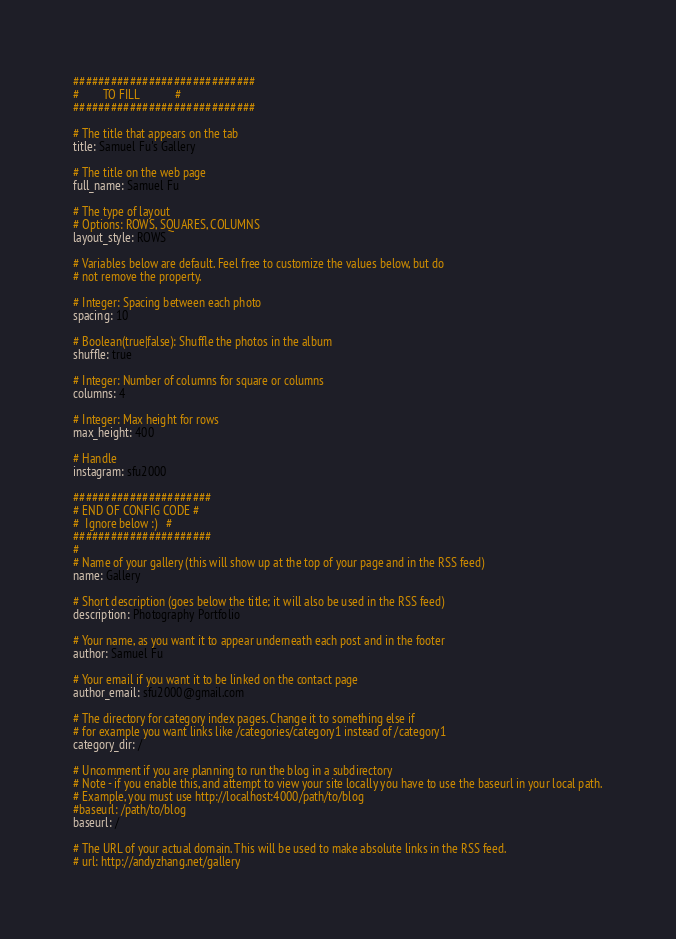<code> <loc_0><loc_0><loc_500><loc_500><_YAML_>#############################
#        TO FILL            #
#############################

# The title that appears on the tab
title: Samuel Fu's Gallery

# The title on the web page
full_name: Samuel Fu

# The type of layout
# Options: ROWS, SQUARES, COLUMNS
layout_style: ROWS

# Variables below are default. Feel free to customize the values below, but do
# not remove the property.

# Integer: Spacing between each photo
spacing: 10

# Boolean(true|false): Shuffle the photos in the album
shuffle: true

# Integer: Number of columns for square or columns
columns: 4

# Integer: Max height for rows
max_height: 400

# Handle
instagram: sfu2000

######################
# END OF CONFIG CODE #
#  Ignore below :)   #
######################
#
# Name of your gallery (this will show up at the top of your page and in the RSS feed)
name: Gallery

# Short description (goes below the title; it will also be used in the RSS feed)
description: Photography Portfolio

# Your name, as you want it to appear underneath each post and in the footer
author: Samuel Fu

# Your email if you want it to be linked on the contact page
author_email: sfu2000@gmail.com

# The directory for category index pages. Change it to something else if
# for example you want links like /categories/category1 instead of /category1
category_dir: /

# Uncomment if you are planning to run the blog in a subdirectory
# Note - if you enable this, and attempt to view your site locally you have to use the baseurl in your local path.
# Example, you must use http://localhost:4000/path/to/blog
#baseurl: /path/to/blog
baseurl: /

# The URL of your actual domain. This will be used to make absolute links in the RSS feed.
# url: http://andyzhang.net/gallery
</code> 